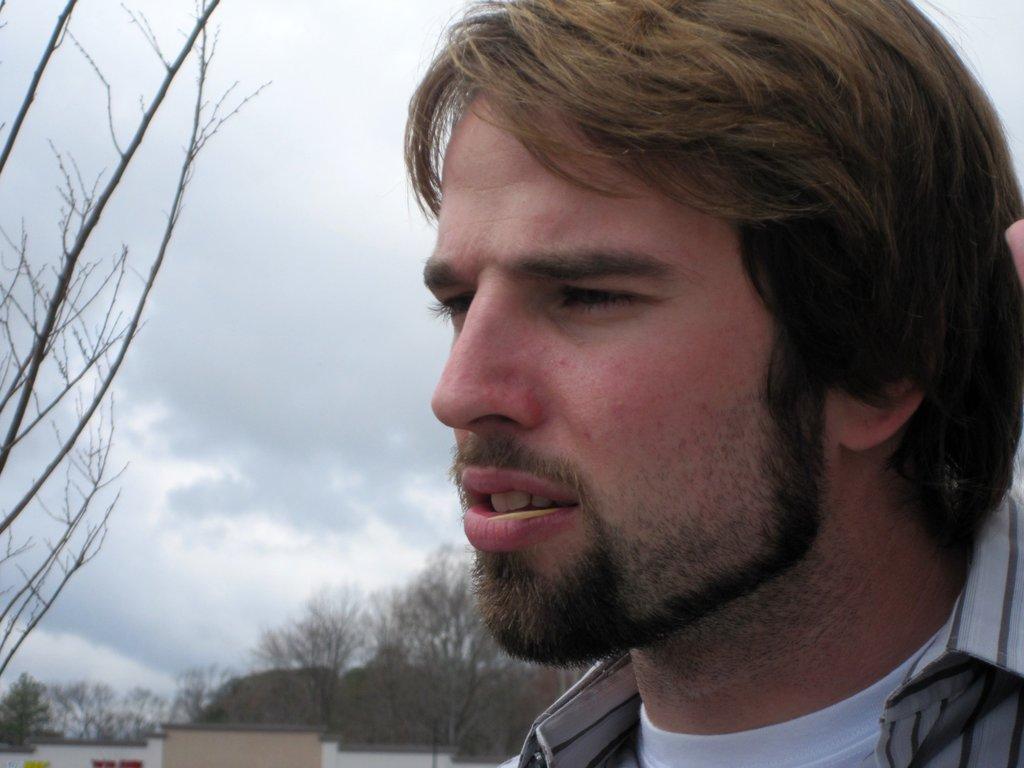Please provide a concise description of this image. In the picture there is a man only the head of the man is visible in the image and behind the man on the left side there is a dry tree and in the background there are many other trees. 